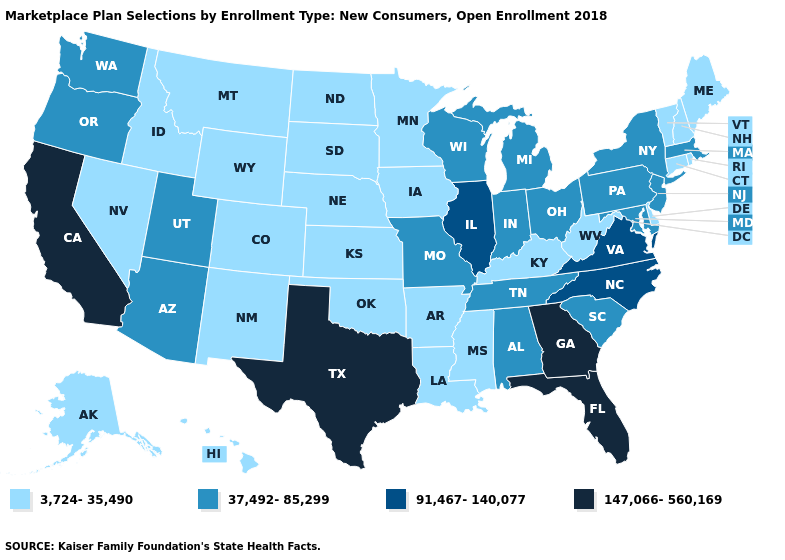What is the value of Delaware?
Short answer required. 3,724-35,490. Name the states that have a value in the range 37,492-85,299?
Give a very brief answer. Alabama, Arizona, Indiana, Maryland, Massachusetts, Michigan, Missouri, New Jersey, New York, Ohio, Oregon, Pennsylvania, South Carolina, Tennessee, Utah, Washington, Wisconsin. What is the highest value in states that border New Hampshire?
Concise answer only. 37,492-85,299. What is the lowest value in the USA?
Write a very short answer. 3,724-35,490. Is the legend a continuous bar?
Answer briefly. No. What is the highest value in the Northeast ?
Give a very brief answer. 37,492-85,299. Which states have the lowest value in the USA?
Quick response, please. Alaska, Arkansas, Colorado, Connecticut, Delaware, Hawaii, Idaho, Iowa, Kansas, Kentucky, Louisiana, Maine, Minnesota, Mississippi, Montana, Nebraska, Nevada, New Hampshire, New Mexico, North Dakota, Oklahoma, Rhode Island, South Dakota, Vermont, West Virginia, Wyoming. Among the states that border Pennsylvania , which have the highest value?
Quick response, please. Maryland, New Jersey, New York, Ohio. Name the states that have a value in the range 3,724-35,490?
Quick response, please. Alaska, Arkansas, Colorado, Connecticut, Delaware, Hawaii, Idaho, Iowa, Kansas, Kentucky, Louisiana, Maine, Minnesota, Mississippi, Montana, Nebraska, Nevada, New Hampshire, New Mexico, North Dakota, Oklahoma, Rhode Island, South Dakota, Vermont, West Virginia, Wyoming. Name the states that have a value in the range 37,492-85,299?
Keep it brief. Alabama, Arizona, Indiana, Maryland, Massachusetts, Michigan, Missouri, New Jersey, New York, Ohio, Oregon, Pennsylvania, South Carolina, Tennessee, Utah, Washington, Wisconsin. Name the states that have a value in the range 37,492-85,299?
Concise answer only. Alabama, Arizona, Indiana, Maryland, Massachusetts, Michigan, Missouri, New Jersey, New York, Ohio, Oregon, Pennsylvania, South Carolina, Tennessee, Utah, Washington, Wisconsin. Name the states that have a value in the range 3,724-35,490?
Answer briefly. Alaska, Arkansas, Colorado, Connecticut, Delaware, Hawaii, Idaho, Iowa, Kansas, Kentucky, Louisiana, Maine, Minnesota, Mississippi, Montana, Nebraska, Nevada, New Hampshire, New Mexico, North Dakota, Oklahoma, Rhode Island, South Dakota, Vermont, West Virginia, Wyoming. What is the highest value in states that border Oregon?
Be succinct. 147,066-560,169. Does the map have missing data?
Be succinct. No. Name the states that have a value in the range 91,467-140,077?
Short answer required. Illinois, North Carolina, Virginia. 